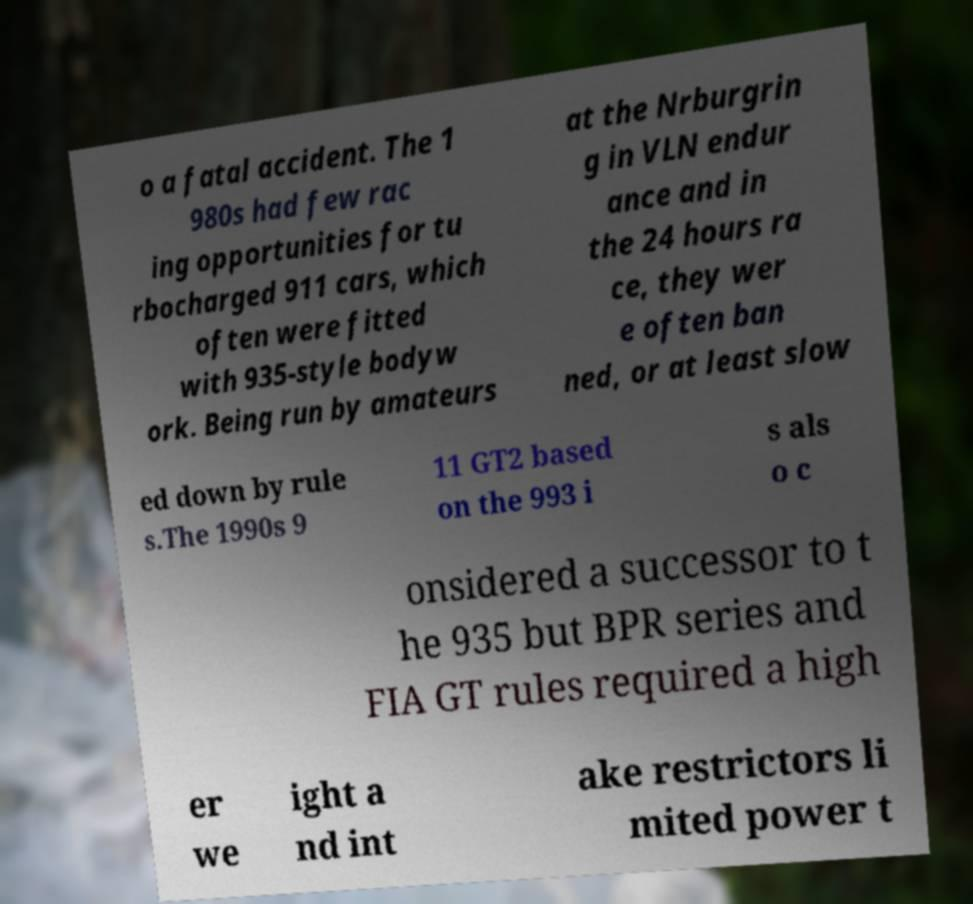There's text embedded in this image that I need extracted. Can you transcribe it verbatim? o a fatal accident. The 1 980s had few rac ing opportunities for tu rbocharged 911 cars, which often were fitted with 935-style bodyw ork. Being run by amateurs at the Nrburgrin g in VLN endur ance and in the 24 hours ra ce, they wer e often ban ned, or at least slow ed down by rule s.The 1990s 9 11 GT2 based on the 993 i s als o c onsidered a successor to t he 935 but BPR series and FIA GT rules required a high er we ight a nd int ake restrictors li mited power t 